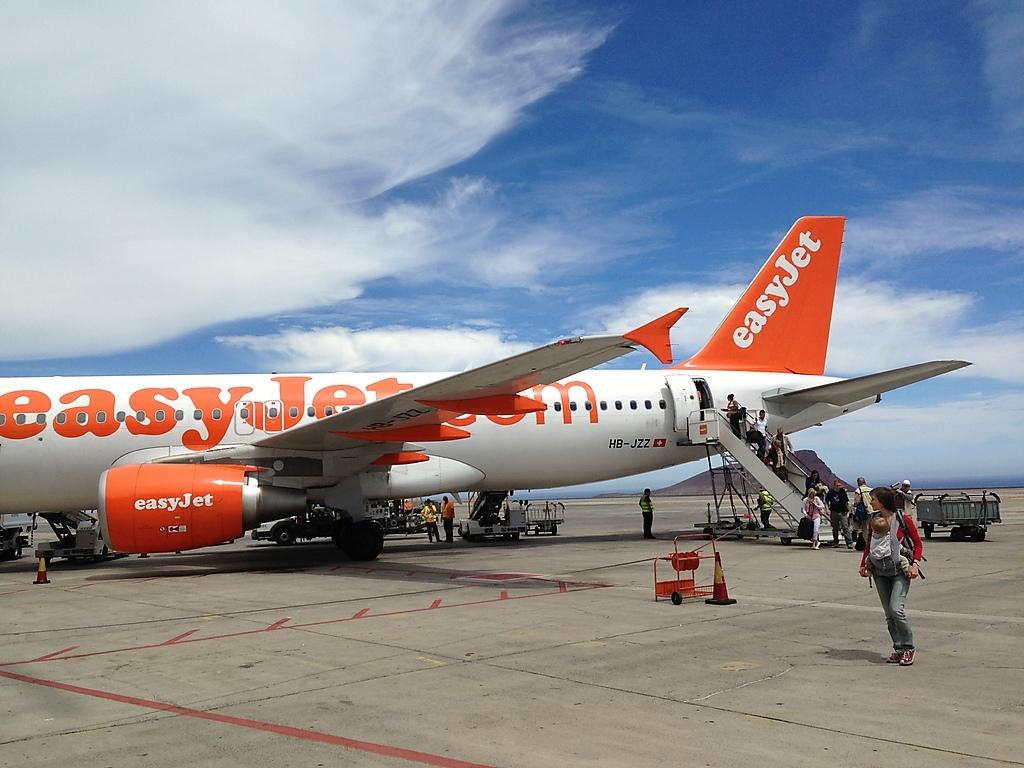<image>
Present a compact description of the photo's key features. Passengers are disembarking from an EasyJet sitting on a runway. 